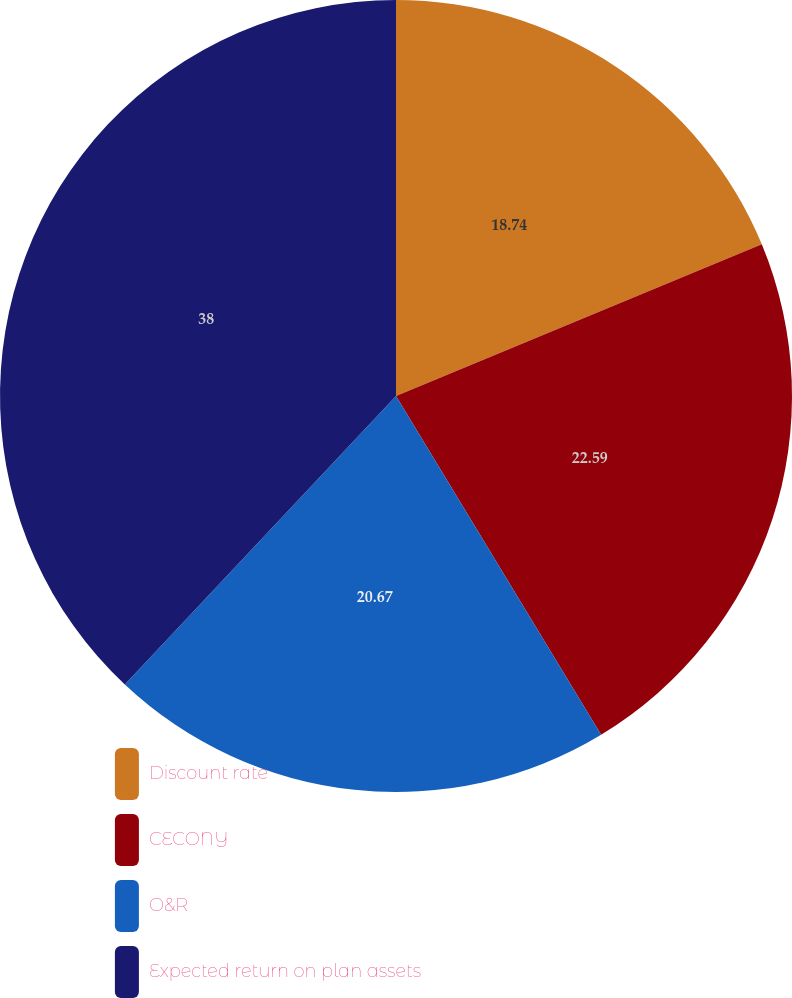Convert chart. <chart><loc_0><loc_0><loc_500><loc_500><pie_chart><fcel>Discount rate<fcel>CECONY<fcel>O&R<fcel>Expected return on plan assets<nl><fcel>18.74%<fcel>22.59%<fcel>20.67%<fcel>37.99%<nl></chart> 